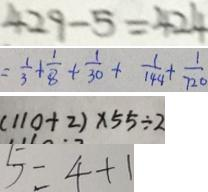<formula> <loc_0><loc_0><loc_500><loc_500>4 2 9 - 5 = 4 2 4 
 = \frac { 1 } { 3 } + \frac { 1 } { 8 } + \frac { 1 } { 3 0 } + \frac { 1 } { 1 4 4 } + \frac { 1 } { 7 2 0 } 
 ( 1 1 0 + 2 ) \times 5 5 \div 2 
 5 = 4 + 1</formula> 